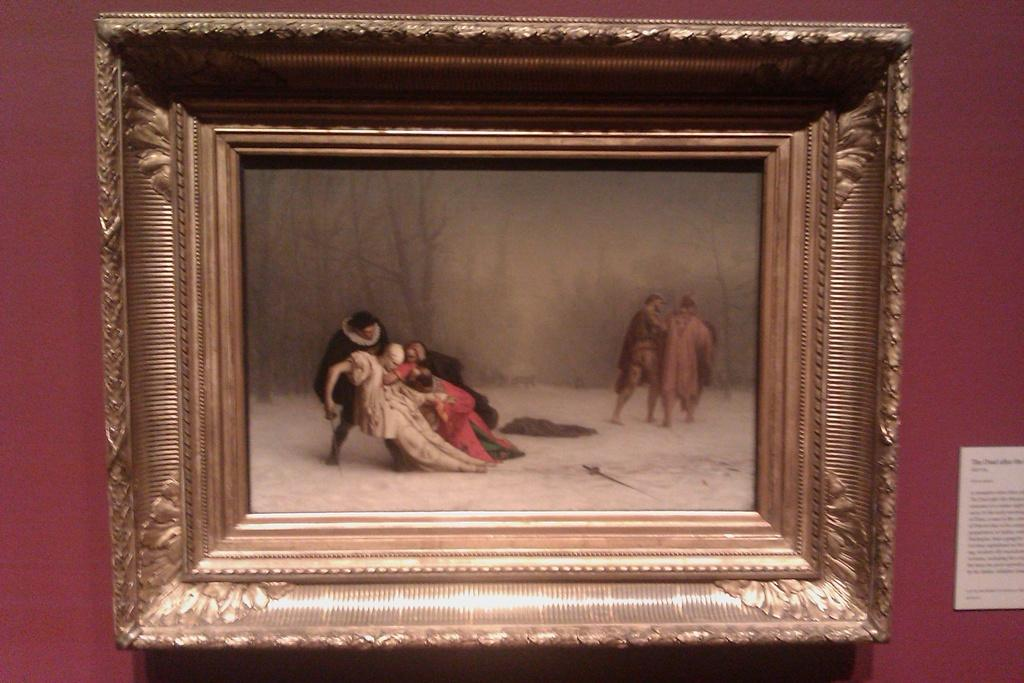What is the main subject in the center of the image? There is a frame in the center of the image. What can be seen within the frame? People are visible within the frame. What is the weather or season suggested by the image? It appears to be snow in the image, suggesting a winter season. What type of vegetation is present in the image? Trees are present in the image. What is located on the right side of the image? There is a poster on the right side of the image. Can you see a boat floating on the snow in the image? There is no boat visible in the image, and the snow suggests a land-based setting rather than a body of water. What type of berry is growing on the trees in the image? There is no mention of berries or any specific type of vegetation on the trees in the image. 